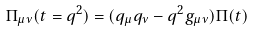Convert formula to latex. <formula><loc_0><loc_0><loc_500><loc_500>\Pi _ { \mu \nu } ( t = q ^ { 2 } ) = ( q _ { \mu } q _ { \nu } - q ^ { 2 } g _ { \mu \nu } ) \Pi ( t )</formula> 